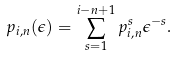<formula> <loc_0><loc_0><loc_500><loc_500>p _ { i , n } ( \epsilon ) = \sum _ { s = 1 } ^ { i - n + 1 } p ^ { s } _ { i , n } \epsilon ^ { - s } .</formula> 